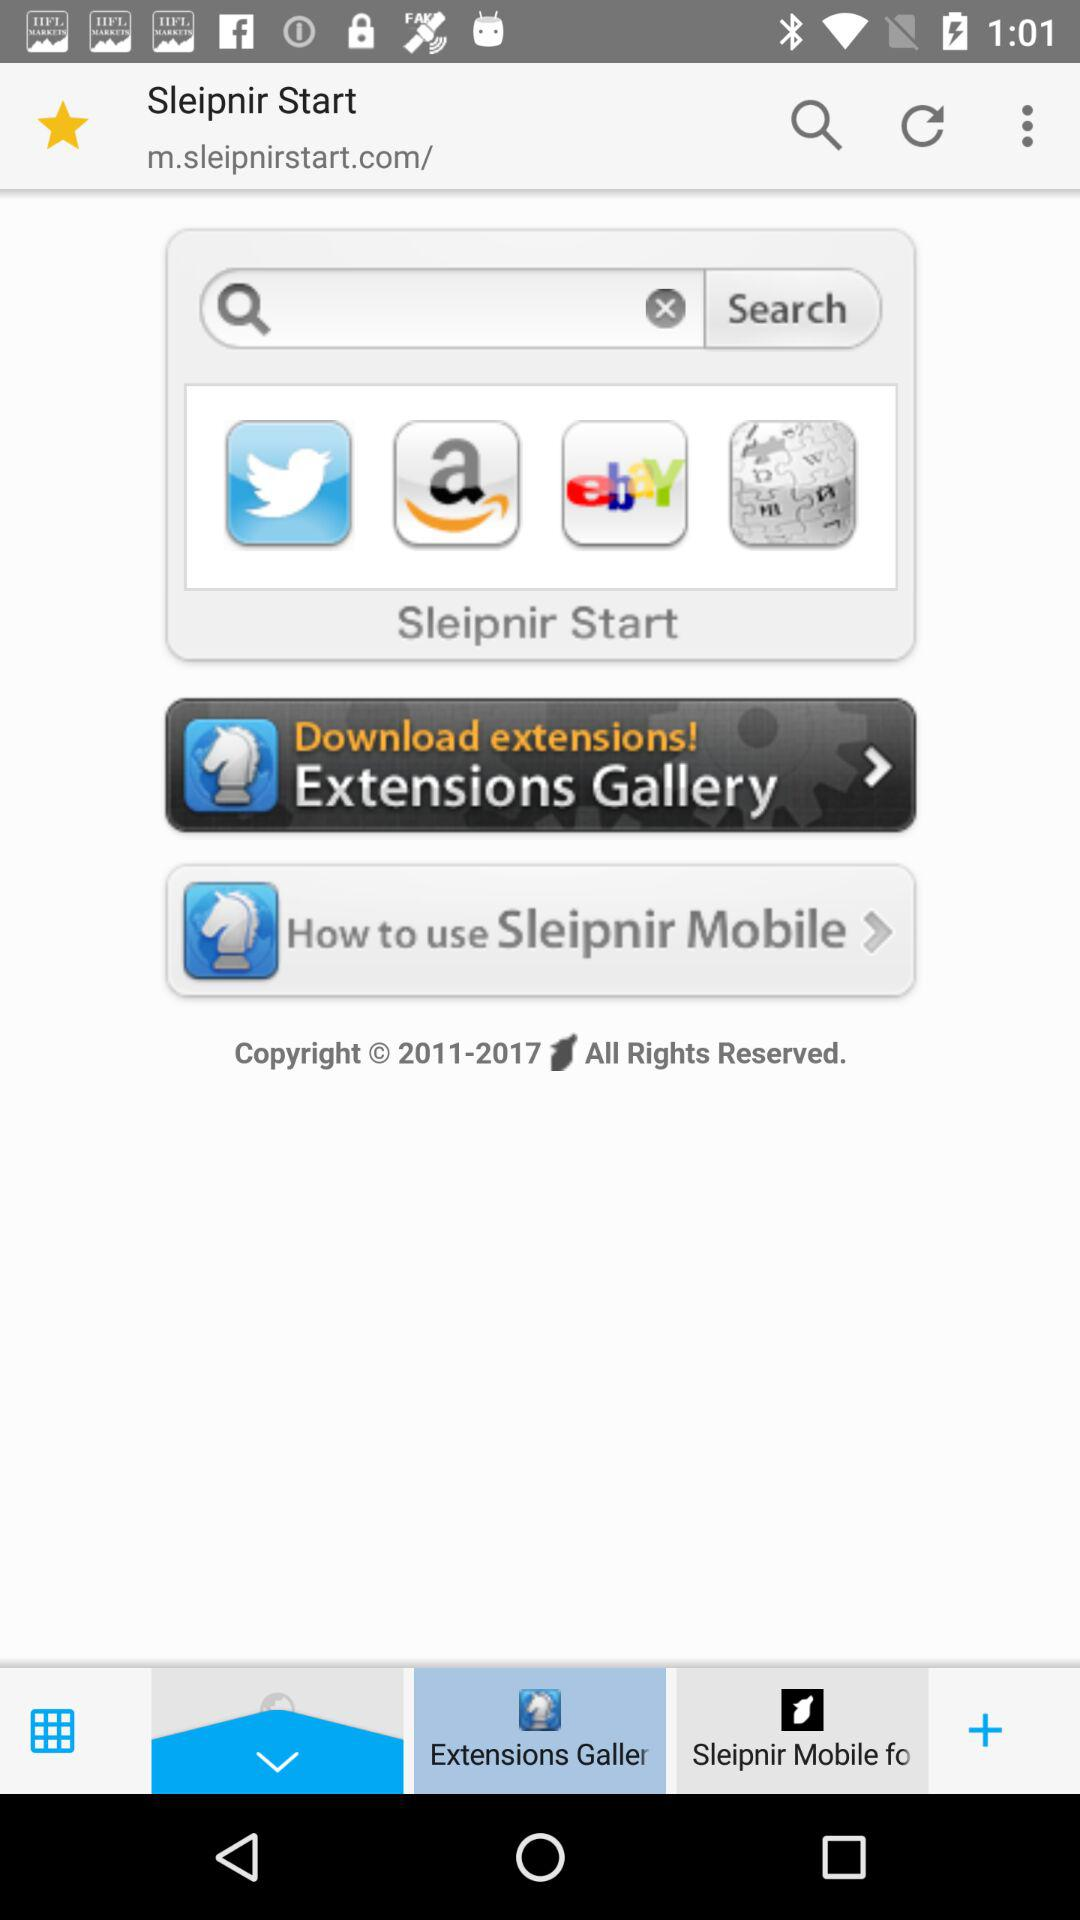What is the copyright year? The copyright year is 2011-2017. 